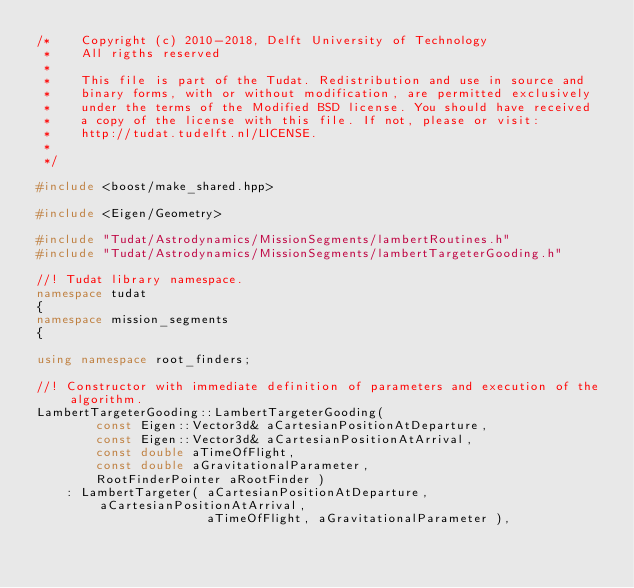<code> <loc_0><loc_0><loc_500><loc_500><_C++_>/*    Copyright (c) 2010-2018, Delft University of Technology
 *    All rigths reserved
 *
 *    This file is part of the Tudat. Redistribution and use in source and
 *    binary forms, with or without modification, are permitted exclusively
 *    under the terms of the Modified BSD license. You should have received
 *    a copy of the license with this file. If not, please or visit:
 *    http://tudat.tudelft.nl/LICENSE.
 *
 */

#include <boost/make_shared.hpp>

#include <Eigen/Geometry>

#include "Tudat/Astrodynamics/MissionSegments/lambertRoutines.h"
#include "Tudat/Astrodynamics/MissionSegments/lambertTargeterGooding.h"

//! Tudat library namespace.
namespace tudat
{
namespace mission_segments
{

using namespace root_finders;

//! Constructor with immediate definition of parameters and execution of the algorithm.
LambertTargeterGooding::LambertTargeterGooding( 
        const Eigen::Vector3d& aCartesianPositionAtDeparture,
        const Eigen::Vector3d& aCartesianPositionAtArrival,
        const double aTimeOfFlight,
        const double aGravitationalParameter,
        RootFinderPointer aRootFinder )
    : LambertTargeter( aCartesianPositionAtDeparture, aCartesianPositionAtArrival,
                       aTimeOfFlight, aGravitationalParameter ),</code> 